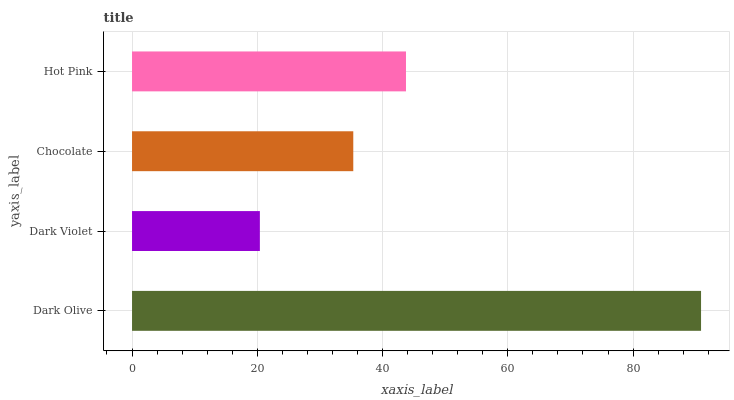Is Dark Violet the minimum?
Answer yes or no. Yes. Is Dark Olive the maximum?
Answer yes or no. Yes. Is Chocolate the minimum?
Answer yes or no. No. Is Chocolate the maximum?
Answer yes or no. No. Is Chocolate greater than Dark Violet?
Answer yes or no. Yes. Is Dark Violet less than Chocolate?
Answer yes or no. Yes. Is Dark Violet greater than Chocolate?
Answer yes or no. No. Is Chocolate less than Dark Violet?
Answer yes or no. No. Is Hot Pink the high median?
Answer yes or no. Yes. Is Chocolate the low median?
Answer yes or no. Yes. Is Dark Olive the high median?
Answer yes or no. No. Is Dark Olive the low median?
Answer yes or no. No. 